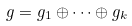Convert formula to latex. <formula><loc_0><loc_0><loc_500><loc_500>g = g _ { 1 } \oplus \dots \oplus g _ { k }</formula> 